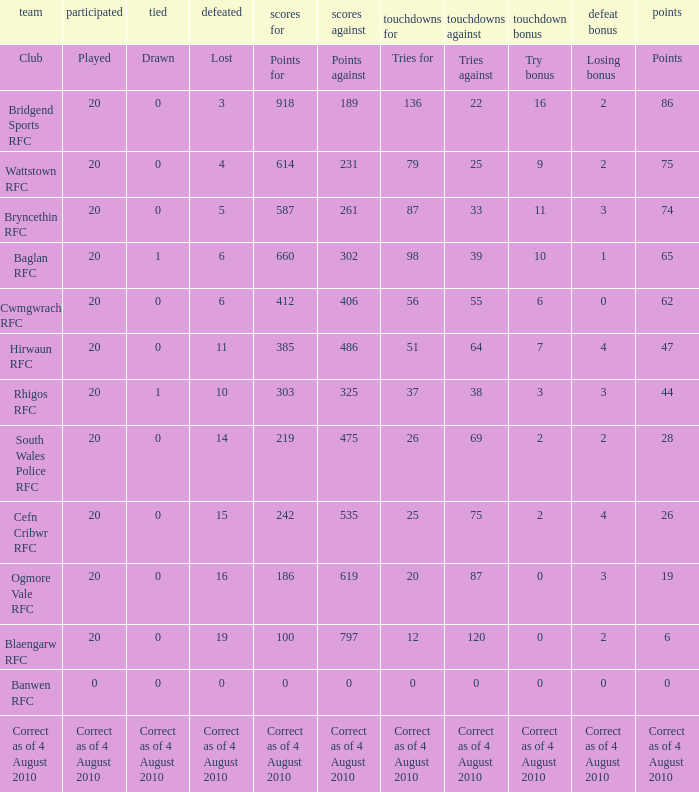What is the tries fow when losing bonus is losing bonus? Tries for. 